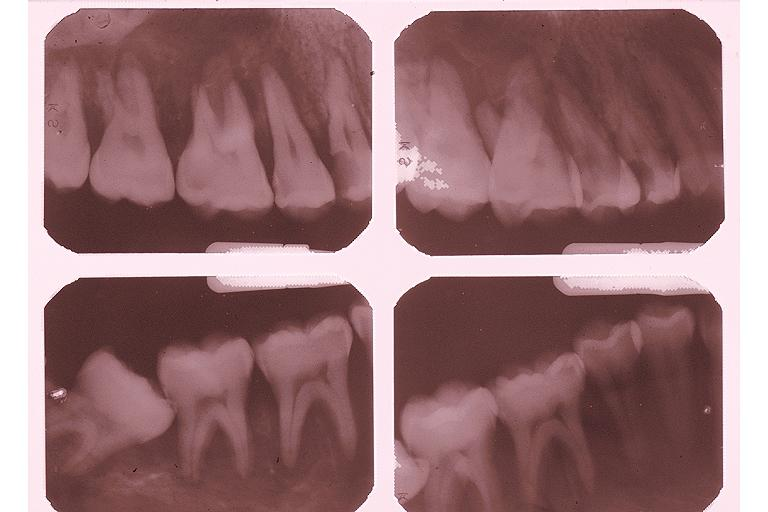what is present?
Answer the question using a single word or phrase. Oral 